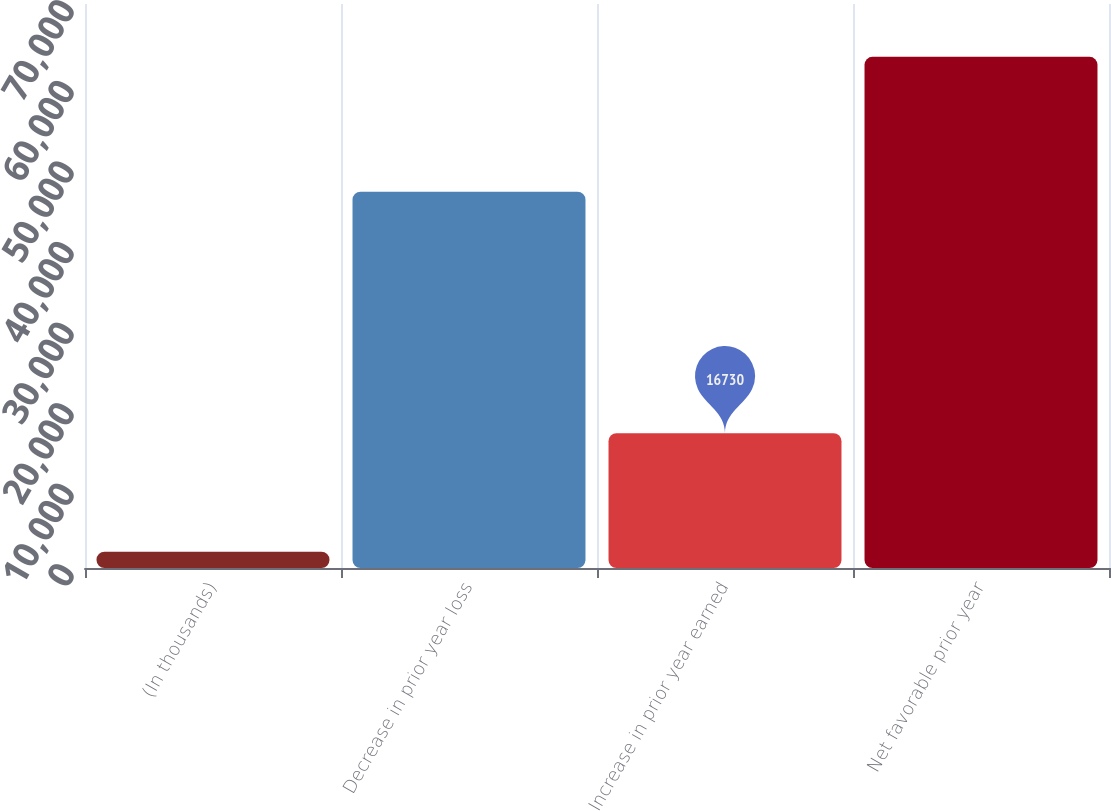<chart> <loc_0><loc_0><loc_500><loc_500><bar_chart><fcel>(In thousands)<fcel>Decrease in prior year loss<fcel>Increase in prior year earned<fcel>Net favorable prior year<nl><fcel>2015<fcel>46713<fcel>16730<fcel>63443<nl></chart> 